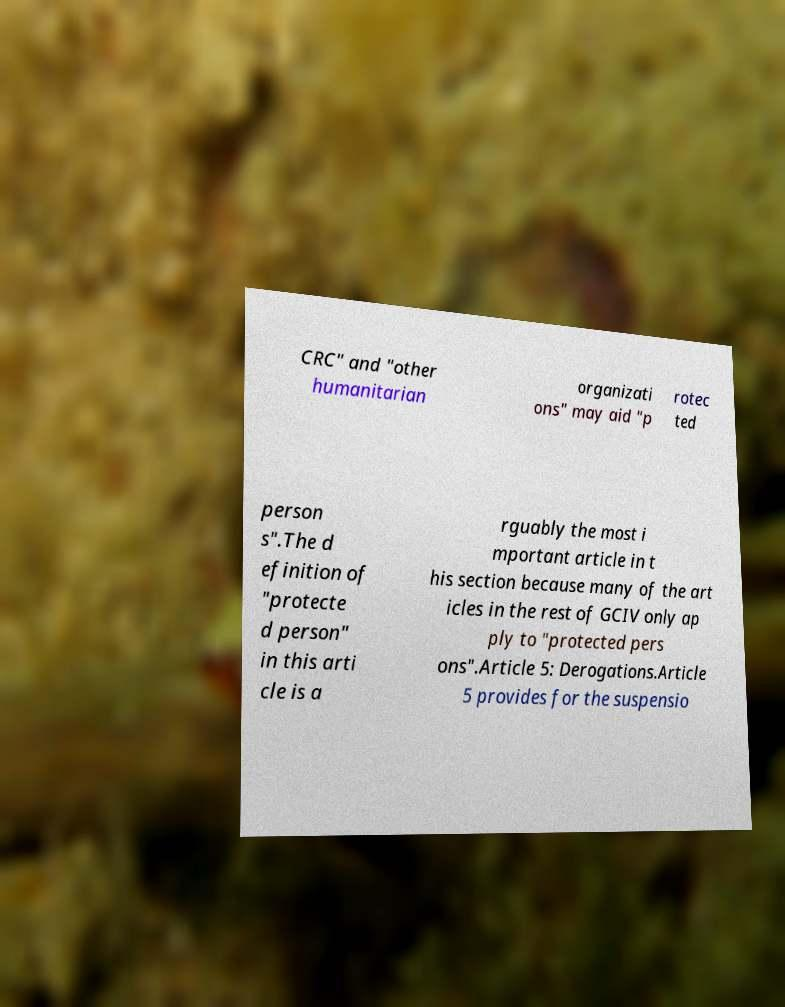Can you accurately transcribe the text from the provided image for me? CRC" and "other humanitarian organizati ons" may aid "p rotec ted person s".The d efinition of "protecte d person" in this arti cle is a rguably the most i mportant article in t his section because many of the art icles in the rest of GCIV only ap ply to "protected pers ons".Article 5: Derogations.Article 5 provides for the suspensio 